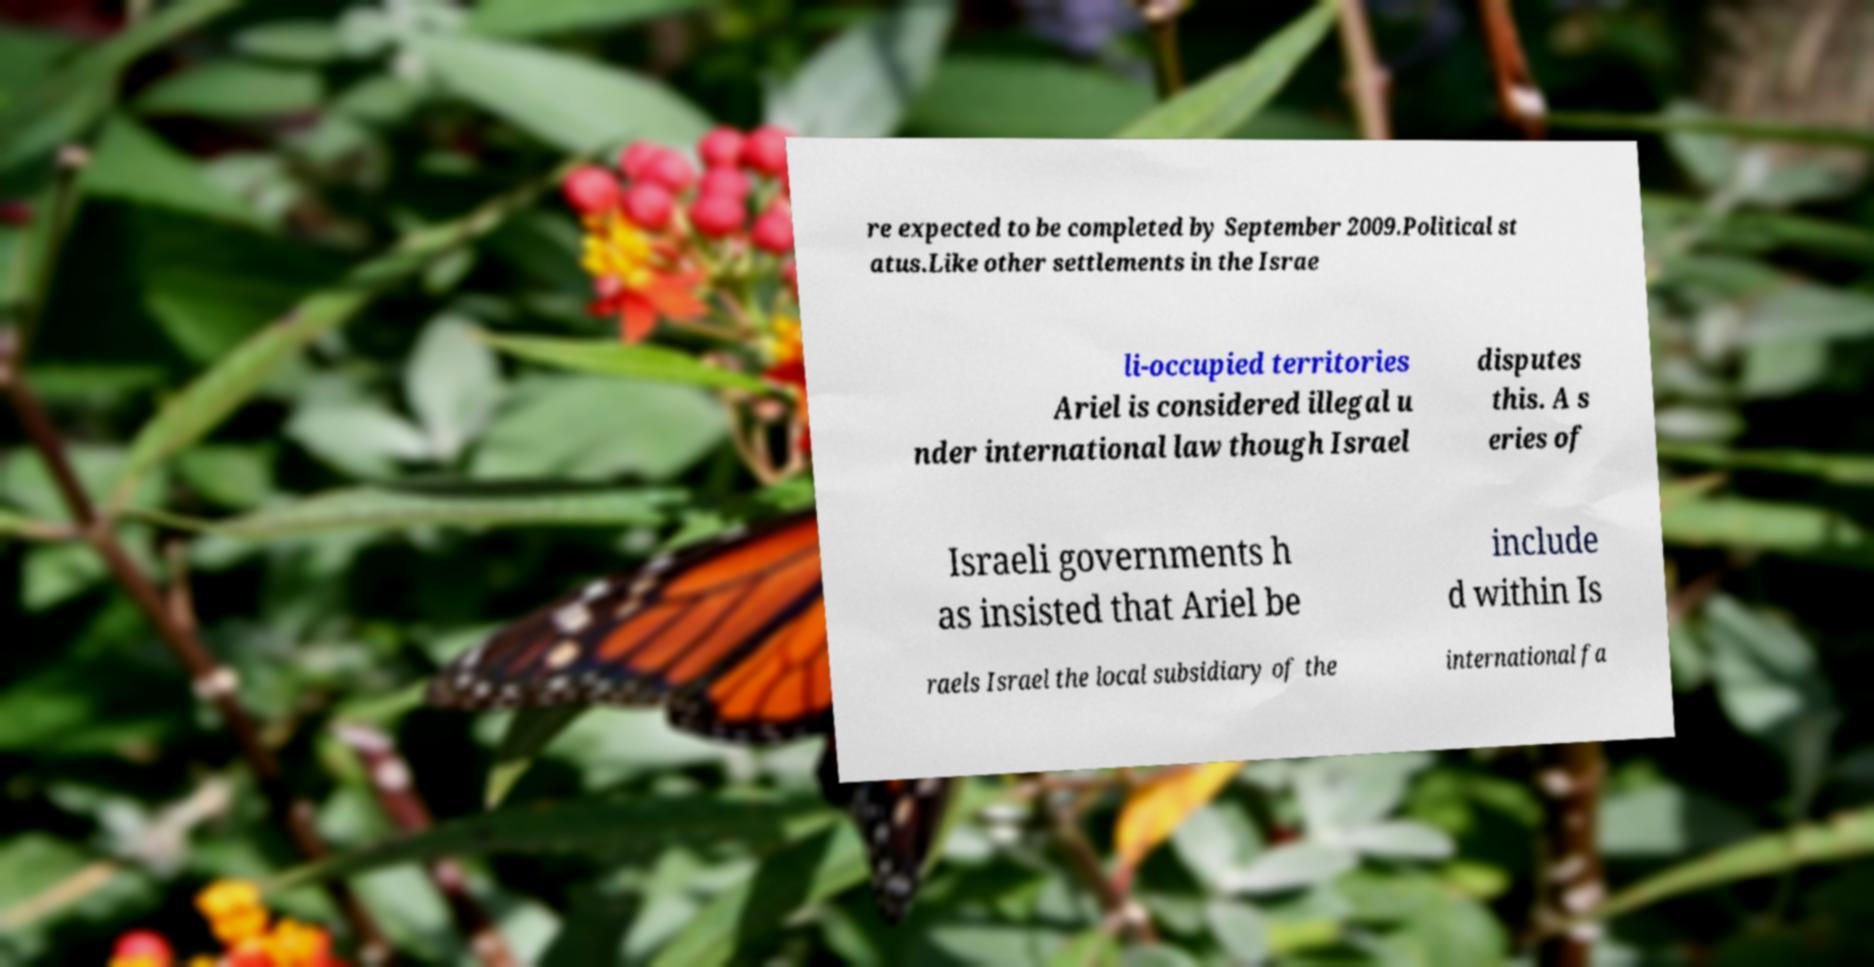For documentation purposes, I need the text within this image transcribed. Could you provide that? re expected to be completed by September 2009.Political st atus.Like other settlements in the Israe li-occupied territories Ariel is considered illegal u nder international law though Israel disputes this. A s eries of Israeli governments h as insisted that Ariel be include d within Is raels Israel the local subsidiary of the international fa 